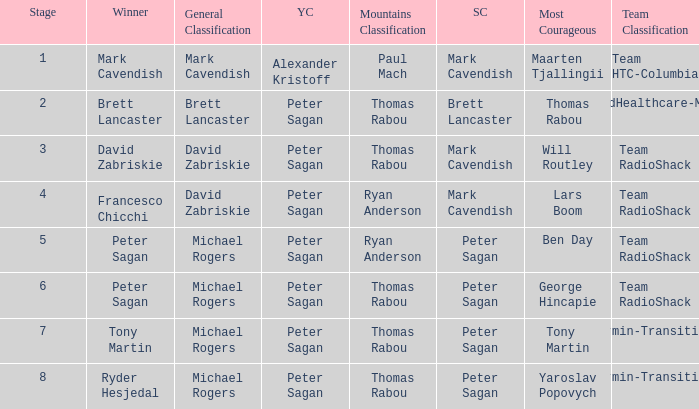When Brett Lancaster won the general classification, who won the team calssification? UnitedHealthcare-Maxxis. 